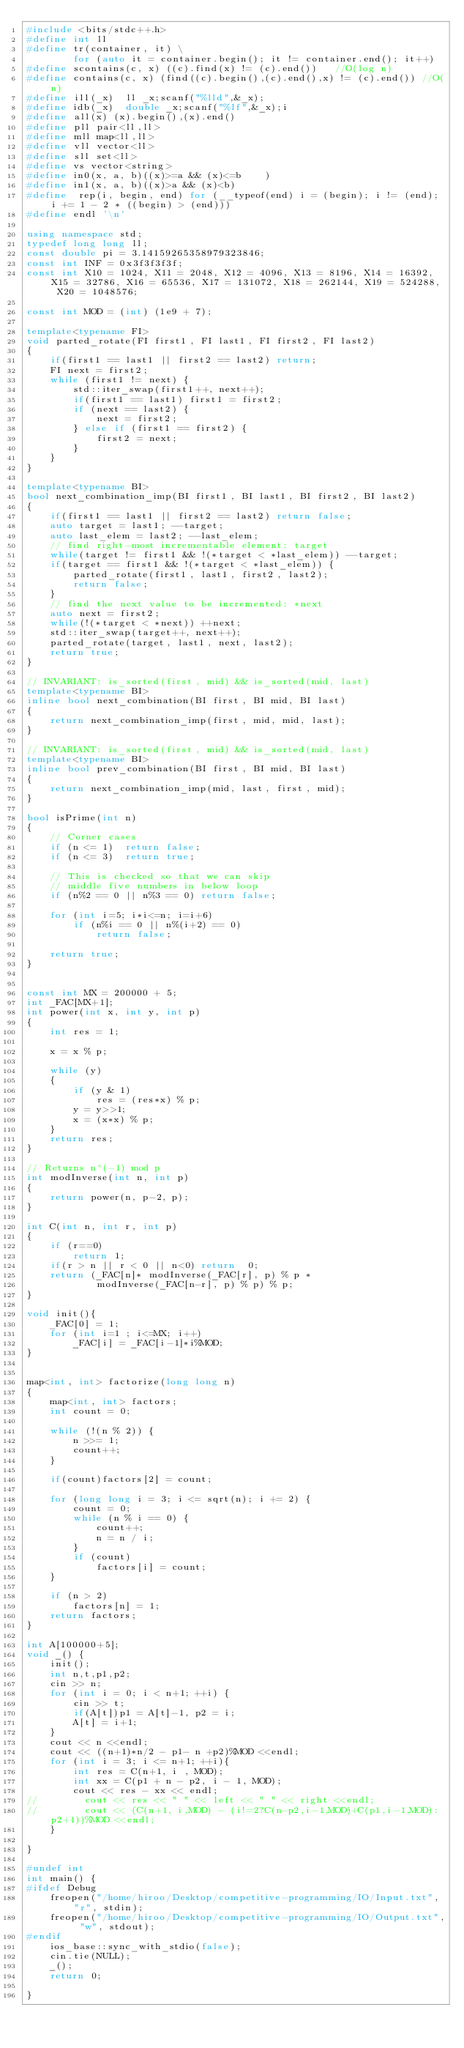<code> <loc_0><loc_0><loc_500><loc_500><_C++_>#include <bits/stdc++.h>
#define int ll
#define tr(container, it) \
        for (auto it = container.begin(); it != container.end(); it++)
#define scontains(c, x) ((c).find(x) != (c).end())   //O(log n)
#define contains(c, x) (find((c).begin(),(c).end(),x) != (c).end()) //O(n)
#define ill(_x)  ll _x;scanf("%lld",&_x);
#define idb(_x)  double _x;scanf("%lf",&_x);i
#define all(x) (x).begin(),(x).end()
#define pll pair<ll,ll>
#define mll map<ll,ll>
#define vll vector<ll>
#define sll set<ll>
#define vs vector<string>
#define in0(x, a, b)((x)>=a && (x)<=b    )
#define in1(x, a, b)((x)>a && (x)<b)
#define  rep(i, begin, end) for (__typeof(end) i = (begin); i != (end); i += 1 - 2 * ((begin) > (end)))
#define endl '\n'

using namespace std;
typedef long long ll;
const double pi = 3.14159265358979323846;
const int INF = 0x3f3f3f3f;
const int X10 = 1024, X11 = 2048, X12 = 4096, X13 = 8196, X14 = 16392, X15 = 32786, X16 = 65536, X17 = 131072, X18 = 262144, X19 = 524288, X20 = 1048576;

const int MOD = (int) (1e9 + 7);

template<typename FI>
void parted_rotate(FI first1, FI last1, FI first2, FI last2)
{
    if(first1 == last1 || first2 == last2) return;
    FI next = first2;
    while (first1 != next) {
        std::iter_swap(first1++, next++);
        if(first1 == last1) first1 = first2;
        if (next == last2) {
            next = first2;
        } else if (first1 == first2) {
            first2 = next;
        }
    }
}

template<typename BI>
bool next_combination_imp(BI first1, BI last1, BI first2, BI last2)
{
    if(first1 == last1 || first2 == last2) return false;
    auto target = last1; --target;
    auto last_elem = last2; --last_elem;
    // find right-most incrementable element: target
    while(target != first1 && !(*target < *last_elem)) --target;
    if(target == first1 && !(*target < *last_elem)) {
        parted_rotate(first1, last1, first2, last2);
        return false;
    }
    // find the next value to be incremented: *next
    auto next = first2;
    while(!(*target < *next)) ++next;
    std::iter_swap(target++, next++);
    parted_rotate(target, last1, next, last2);
    return true;
}

// INVARIANT: is_sorted(first, mid) && is_sorted(mid, last)
template<typename BI>
inline bool next_combination(BI first, BI mid, BI last)
{
    return next_combination_imp(first, mid, mid, last);
}

// INVARIANT: is_sorted(first, mid) && is_sorted(mid, last)
template<typename BI>
inline bool prev_combination(BI first, BI mid, BI last)
{
    return next_combination_imp(mid, last, first, mid);
}

bool isPrime(int n)
{
    // Corner cases
    if (n <= 1)  return false;
    if (n <= 3)  return true;

    // This is checked so that we can skip
    // middle five numbers in below loop
    if (n%2 == 0 || n%3 == 0) return false;

    for (int i=5; i*i<=n; i=i+6)
        if (n%i == 0 || n%(i+2) == 0)
            return false;

    return true;
}


const int MX = 200000 + 5;
int _FAC[MX+1];
int power(int x, int y, int p)
{
    int res = 1;

    x = x % p;

    while (y)
    {
        if (y & 1)
            res = (res*x) % p;
        y = y>>1;
        x = (x*x) % p;
    }
    return res;
}

// Returns n^(-1) mod p
int modInverse(int n, int p)
{
    return power(n, p-2, p);
}

int C(int n, int r, int p)
{
    if (r==0)
        return 1;
    if(r > n || r < 0 || n<0) return  0;
    return (_FAC[n]* modInverse(_FAC[r], p) % p *
            modInverse(_FAC[n-r], p) % p) % p;
}

void init(){
    _FAC[0] = 1;
    for (int i=1 ; i<=MX; i++)
        _FAC[i] = _FAC[i-1]*i%MOD;
}


map<int, int> factorize(long long n)
{
    map<int, int> factors;
    int count = 0;

    while (!(n % 2)) {
        n >>= 1;
        count++;
    }

    if(count)factors[2] = count;

    for (long long i = 3; i <= sqrt(n); i += 2) {
        count = 0;
        while (n % i == 0) {
            count++;
            n = n / i;
        }
        if (count)
            factors[i] = count;
    }

    if (n > 2)
        factors[n] = 1;
    return factors;
}

int A[100000+5];
void _() {
    init();
    int n,t,p1,p2;
    cin >> n;
    for (int i = 0; i < n+1; ++i) {
        cin >> t;
        if(A[t])p1 = A[t]-1, p2 = i;
        A[t] = i+1;
    }
    cout << n <<endl;
    cout << ((n+1)*n/2 - p1- n +p2)%MOD <<endl;
    for (int i = 3; i <= n+1; ++i){
        int res = C(n+1, i , MOD);
        int xx = C(p1 + n - p2, i - 1, MOD);
        cout << res - xx << endl;
//        cout << res << " " << left << " " << right <<endl;
//        cout << (C(n+1, i,MOD) - (i!=2?C(n-p2,i-1,MOD)+C(p1,i-1,MOD):p2+1))%MOD <<endl;
    }

}

#undef int
int main() {
#ifdef Debug
    freopen("/home/hiroo/Desktop/competitive-programming/IO/Input.txt", "r", stdin);
    freopen("/home/hiroo/Desktop/competitive-programming/IO/Output.txt", "w", stdout);
#endif
    ios_base::sync_with_stdio(false);
    cin.tie(NULL);
    _();
    return 0;

}


</code> 